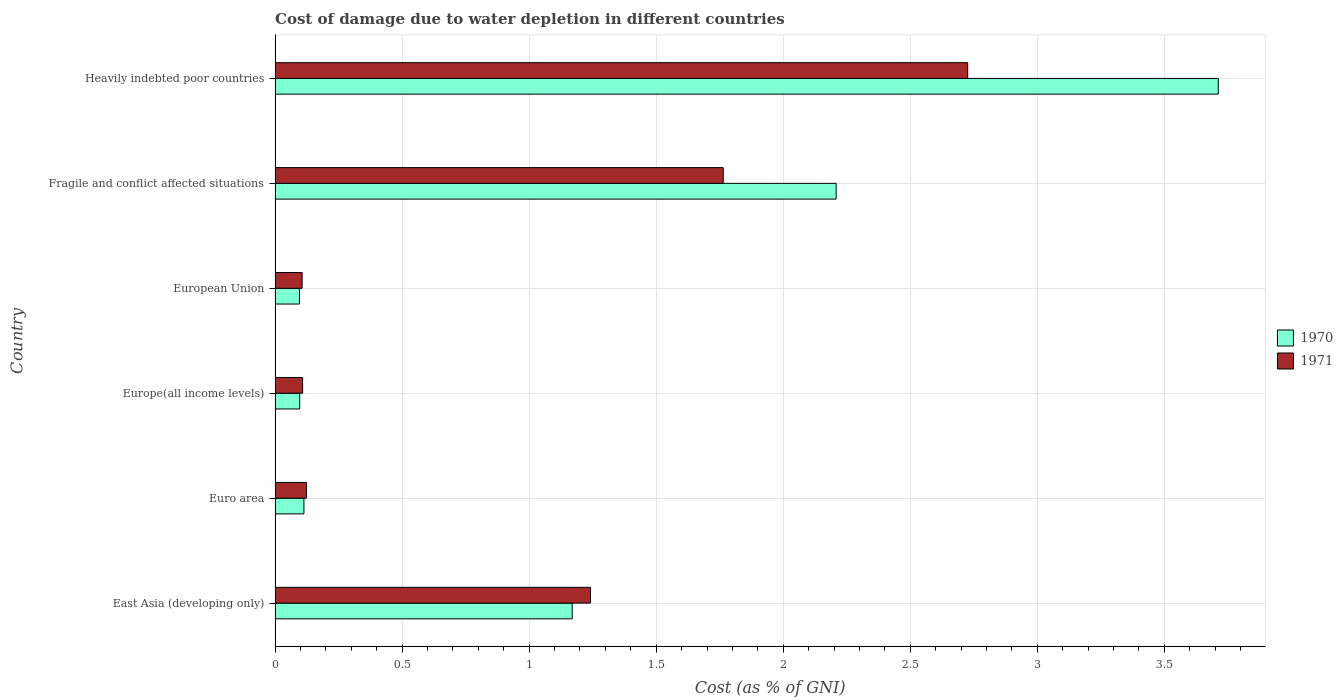How many different coloured bars are there?
Your response must be concise. 2. Are the number of bars per tick equal to the number of legend labels?
Provide a succinct answer. Yes. Are the number of bars on each tick of the Y-axis equal?
Provide a short and direct response. Yes. What is the label of the 2nd group of bars from the top?
Offer a very short reply. Fragile and conflict affected situations. What is the cost of damage caused due to water depletion in 1970 in Europe(all income levels)?
Provide a short and direct response. 0.1. Across all countries, what is the maximum cost of damage caused due to water depletion in 1971?
Give a very brief answer. 2.73. Across all countries, what is the minimum cost of damage caused due to water depletion in 1971?
Provide a short and direct response. 0.11. In which country was the cost of damage caused due to water depletion in 1971 maximum?
Your answer should be very brief. Heavily indebted poor countries. What is the total cost of damage caused due to water depletion in 1970 in the graph?
Offer a terse response. 7.4. What is the difference between the cost of damage caused due to water depletion in 1970 in European Union and that in Fragile and conflict affected situations?
Your answer should be compact. -2.11. What is the difference between the cost of damage caused due to water depletion in 1971 in European Union and the cost of damage caused due to water depletion in 1970 in Fragile and conflict affected situations?
Keep it short and to the point. -2.1. What is the average cost of damage caused due to water depletion in 1970 per country?
Your response must be concise. 1.23. What is the difference between the cost of damage caused due to water depletion in 1971 and cost of damage caused due to water depletion in 1970 in Heavily indebted poor countries?
Offer a terse response. -0.99. In how many countries, is the cost of damage caused due to water depletion in 1970 greater than 1.9 %?
Ensure brevity in your answer.  2. What is the ratio of the cost of damage caused due to water depletion in 1970 in Europe(all income levels) to that in European Union?
Your response must be concise. 1.01. Is the cost of damage caused due to water depletion in 1970 in Fragile and conflict affected situations less than that in Heavily indebted poor countries?
Offer a terse response. Yes. What is the difference between the highest and the second highest cost of damage caused due to water depletion in 1971?
Keep it short and to the point. 0.96. What is the difference between the highest and the lowest cost of damage caused due to water depletion in 1971?
Your answer should be compact. 2.62. How many bars are there?
Your response must be concise. 12. What is the difference between two consecutive major ticks on the X-axis?
Give a very brief answer. 0.5. Are the values on the major ticks of X-axis written in scientific E-notation?
Ensure brevity in your answer.  No. Does the graph contain grids?
Ensure brevity in your answer.  Yes. How are the legend labels stacked?
Offer a terse response. Vertical. What is the title of the graph?
Give a very brief answer. Cost of damage due to water depletion in different countries. Does "1963" appear as one of the legend labels in the graph?
Ensure brevity in your answer.  No. What is the label or title of the X-axis?
Offer a terse response. Cost (as % of GNI). What is the label or title of the Y-axis?
Provide a short and direct response. Country. What is the Cost (as % of GNI) in 1970 in East Asia (developing only)?
Give a very brief answer. 1.17. What is the Cost (as % of GNI) in 1971 in East Asia (developing only)?
Offer a terse response. 1.24. What is the Cost (as % of GNI) of 1970 in Euro area?
Your answer should be very brief. 0.11. What is the Cost (as % of GNI) of 1971 in Euro area?
Offer a terse response. 0.12. What is the Cost (as % of GNI) in 1970 in Europe(all income levels)?
Make the answer very short. 0.1. What is the Cost (as % of GNI) of 1971 in Europe(all income levels)?
Your answer should be very brief. 0.11. What is the Cost (as % of GNI) in 1970 in European Union?
Give a very brief answer. 0.1. What is the Cost (as % of GNI) in 1971 in European Union?
Make the answer very short. 0.11. What is the Cost (as % of GNI) in 1970 in Fragile and conflict affected situations?
Offer a very short reply. 2.21. What is the Cost (as % of GNI) in 1971 in Fragile and conflict affected situations?
Provide a succinct answer. 1.76. What is the Cost (as % of GNI) of 1970 in Heavily indebted poor countries?
Provide a short and direct response. 3.71. What is the Cost (as % of GNI) of 1971 in Heavily indebted poor countries?
Provide a succinct answer. 2.73. Across all countries, what is the maximum Cost (as % of GNI) of 1970?
Ensure brevity in your answer.  3.71. Across all countries, what is the maximum Cost (as % of GNI) of 1971?
Your answer should be very brief. 2.73. Across all countries, what is the minimum Cost (as % of GNI) of 1970?
Ensure brevity in your answer.  0.1. Across all countries, what is the minimum Cost (as % of GNI) of 1971?
Your answer should be compact. 0.11. What is the total Cost (as % of GNI) of 1970 in the graph?
Your response must be concise. 7.4. What is the total Cost (as % of GNI) of 1971 in the graph?
Ensure brevity in your answer.  6.07. What is the difference between the Cost (as % of GNI) in 1970 in East Asia (developing only) and that in Euro area?
Your answer should be compact. 1.06. What is the difference between the Cost (as % of GNI) of 1971 in East Asia (developing only) and that in Euro area?
Make the answer very short. 1.12. What is the difference between the Cost (as % of GNI) of 1970 in East Asia (developing only) and that in Europe(all income levels)?
Offer a terse response. 1.07. What is the difference between the Cost (as % of GNI) of 1971 in East Asia (developing only) and that in Europe(all income levels)?
Make the answer very short. 1.13. What is the difference between the Cost (as % of GNI) of 1970 in East Asia (developing only) and that in European Union?
Offer a very short reply. 1.07. What is the difference between the Cost (as % of GNI) of 1971 in East Asia (developing only) and that in European Union?
Your answer should be very brief. 1.13. What is the difference between the Cost (as % of GNI) of 1970 in East Asia (developing only) and that in Fragile and conflict affected situations?
Offer a very short reply. -1.04. What is the difference between the Cost (as % of GNI) in 1971 in East Asia (developing only) and that in Fragile and conflict affected situations?
Give a very brief answer. -0.52. What is the difference between the Cost (as % of GNI) in 1970 in East Asia (developing only) and that in Heavily indebted poor countries?
Offer a terse response. -2.54. What is the difference between the Cost (as % of GNI) of 1971 in East Asia (developing only) and that in Heavily indebted poor countries?
Provide a short and direct response. -1.48. What is the difference between the Cost (as % of GNI) in 1970 in Euro area and that in Europe(all income levels)?
Provide a succinct answer. 0.02. What is the difference between the Cost (as % of GNI) of 1971 in Euro area and that in Europe(all income levels)?
Ensure brevity in your answer.  0.02. What is the difference between the Cost (as % of GNI) in 1970 in Euro area and that in European Union?
Provide a short and direct response. 0.02. What is the difference between the Cost (as % of GNI) of 1971 in Euro area and that in European Union?
Give a very brief answer. 0.02. What is the difference between the Cost (as % of GNI) in 1970 in Euro area and that in Fragile and conflict affected situations?
Your answer should be very brief. -2.09. What is the difference between the Cost (as % of GNI) of 1971 in Euro area and that in Fragile and conflict affected situations?
Your answer should be very brief. -1.64. What is the difference between the Cost (as % of GNI) of 1970 in Euro area and that in Heavily indebted poor countries?
Offer a very short reply. -3.6. What is the difference between the Cost (as % of GNI) in 1971 in Euro area and that in Heavily indebted poor countries?
Keep it short and to the point. -2.6. What is the difference between the Cost (as % of GNI) in 1970 in Europe(all income levels) and that in European Union?
Offer a terse response. 0. What is the difference between the Cost (as % of GNI) in 1971 in Europe(all income levels) and that in European Union?
Your response must be concise. 0. What is the difference between the Cost (as % of GNI) in 1970 in Europe(all income levels) and that in Fragile and conflict affected situations?
Offer a terse response. -2.11. What is the difference between the Cost (as % of GNI) of 1971 in Europe(all income levels) and that in Fragile and conflict affected situations?
Your answer should be compact. -1.66. What is the difference between the Cost (as % of GNI) of 1970 in Europe(all income levels) and that in Heavily indebted poor countries?
Ensure brevity in your answer.  -3.62. What is the difference between the Cost (as % of GNI) in 1971 in Europe(all income levels) and that in Heavily indebted poor countries?
Offer a terse response. -2.62. What is the difference between the Cost (as % of GNI) in 1970 in European Union and that in Fragile and conflict affected situations?
Your response must be concise. -2.11. What is the difference between the Cost (as % of GNI) of 1971 in European Union and that in Fragile and conflict affected situations?
Keep it short and to the point. -1.66. What is the difference between the Cost (as % of GNI) in 1970 in European Union and that in Heavily indebted poor countries?
Your answer should be very brief. -3.62. What is the difference between the Cost (as % of GNI) in 1971 in European Union and that in Heavily indebted poor countries?
Your answer should be very brief. -2.62. What is the difference between the Cost (as % of GNI) in 1970 in Fragile and conflict affected situations and that in Heavily indebted poor countries?
Your answer should be very brief. -1.5. What is the difference between the Cost (as % of GNI) of 1971 in Fragile and conflict affected situations and that in Heavily indebted poor countries?
Ensure brevity in your answer.  -0.96. What is the difference between the Cost (as % of GNI) of 1970 in East Asia (developing only) and the Cost (as % of GNI) of 1971 in Euro area?
Your response must be concise. 1.05. What is the difference between the Cost (as % of GNI) of 1970 in East Asia (developing only) and the Cost (as % of GNI) of 1971 in Europe(all income levels)?
Offer a very short reply. 1.06. What is the difference between the Cost (as % of GNI) of 1970 in East Asia (developing only) and the Cost (as % of GNI) of 1971 in European Union?
Make the answer very short. 1.06. What is the difference between the Cost (as % of GNI) of 1970 in East Asia (developing only) and the Cost (as % of GNI) of 1971 in Fragile and conflict affected situations?
Your response must be concise. -0.59. What is the difference between the Cost (as % of GNI) in 1970 in East Asia (developing only) and the Cost (as % of GNI) in 1971 in Heavily indebted poor countries?
Your answer should be very brief. -1.56. What is the difference between the Cost (as % of GNI) in 1970 in Euro area and the Cost (as % of GNI) in 1971 in Europe(all income levels)?
Offer a very short reply. 0.01. What is the difference between the Cost (as % of GNI) of 1970 in Euro area and the Cost (as % of GNI) of 1971 in European Union?
Make the answer very short. 0.01. What is the difference between the Cost (as % of GNI) in 1970 in Euro area and the Cost (as % of GNI) in 1971 in Fragile and conflict affected situations?
Give a very brief answer. -1.65. What is the difference between the Cost (as % of GNI) in 1970 in Euro area and the Cost (as % of GNI) in 1971 in Heavily indebted poor countries?
Your response must be concise. -2.61. What is the difference between the Cost (as % of GNI) in 1970 in Europe(all income levels) and the Cost (as % of GNI) in 1971 in European Union?
Keep it short and to the point. -0.01. What is the difference between the Cost (as % of GNI) in 1970 in Europe(all income levels) and the Cost (as % of GNI) in 1971 in Fragile and conflict affected situations?
Ensure brevity in your answer.  -1.67. What is the difference between the Cost (as % of GNI) in 1970 in Europe(all income levels) and the Cost (as % of GNI) in 1971 in Heavily indebted poor countries?
Keep it short and to the point. -2.63. What is the difference between the Cost (as % of GNI) of 1970 in European Union and the Cost (as % of GNI) of 1971 in Fragile and conflict affected situations?
Offer a terse response. -1.67. What is the difference between the Cost (as % of GNI) in 1970 in European Union and the Cost (as % of GNI) in 1971 in Heavily indebted poor countries?
Offer a terse response. -2.63. What is the difference between the Cost (as % of GNI) of 1970 in Fragile and conflict affected situations and the Cost (as % of GNI) of 1971 in Heavily indebted poor countries?
Make the answer very short. -0.52. What is the average Cost (as % of GNI) of 1970 per country?
Provide a succinct answer. 1.23. What is the average Cost (as % of GNI) of 1971 per country?
Offer a terse response. 1.01. What is the difference between the Cost (as % of GNI) in 1970 and Cost (as % of GNI) in 1971 in East Asia (developing only)?
Your answer should be very brief. -0.07. What is the difference between the Cost (as % of GNI) of 1970 and Cost (as % of GNI) of 1971 in Euro area?
Keep it short and to the point. -0.01. What is the difference between the Cost (as % of GNI) in 1970 and Cost (as % of GNI) in 1971 in Europe(all income levels)?
Offer a terse response. -0.01. What is the difference between the Cost (as % of GNI) in 1970 and Cost (as % of GNI) in 1971 in European Union?
Your response must be concise. -0.01. What is the difference between the Cost (as % of GNI) of 1970 and Cost (as % of GNI) of 1971 in Fragile and conflict affected situations?
Keep it short and to the point. 0.44. What is the difference between the Cost (as % of GNI) of 1970 and Cost (as % of GNI) of 1971 in Heavily indebted poor countries?
Give a very brief answer. 0.99. What is the ratio of the Cost (as % of GNI) of 1970 in East Asia (developing only) to that in Euro area?
Offer a very short reply. 10.3. What is the ratio of the Cost (as % of GNI) in 1971 in East Asia (developing only) to that in Euro area?
Your answer should be compact. 10.06. What is the ratio of the Cost (as % of GNI) in 1970 in East Asia (developing only) to that in Europe(all income levels)?
Provide a short and direct response. 12.06. What is the ratio of the Cost (as % of GNI) in 1971 in East Asia (developing only) to that in Europe(all income levels)?
Keep it short and to the point. 11.46. What is the ratio of the Cost (as % of GNI) of 1970 in East Asia (developing only) to that in European Union?
Your answer should be compact. 12.18. What is the ratio of the Cost (as % of GNI) of 1971 in East Asia (developing only) to that in European Union?
Make the answer very short. 11.67. What is the ratio of the Cost (as % of GNI) of 1970 in East Asia (developing only) to that in Fragile and conflict affected situations?
Provide a short and direct response. 0.53. What is the ratio of the Cost (as % of GNI) of 1971 in East Asia (developing only) to that in Fragile and conflict affected situations?
Keep it short and to the point. 0.7. What is the ratio of the Cost (as % of GNI) in 1970 in East Asia (developing only) to that in Heavily indebted poor countries?
Your answer should be compact. 0.32. What is the ratio of the Cost (as % of GNI) in 1971 in East Asia (developing only) to that in Heavily indebted poor countries?
Give a very brief answer. 0.46. What is the ratio of the Cost (as % of GNI) in 1970 in Euro area to that in Europe(all income levels)?
Your answer should be compact. 1.17. What is the ratio of the Cost (as % of GNI) in 1971 in Euro area to that in Europe(all income levels)?
Make the answer very short. 1.14. What is the ratio of the Cost (as % of GNI) of 1970 in Euro area to that in European Union?
Ensure brevity in your answer.  1.18. What is the ratio of the Cost (as % of GNI) in 1971 in Euro area to that in European Union?
Give a very brief answer. 1.16. What is the ratio of the Cost (as % of GNI) in 1970 in Euro area to that in Fragile and conflict affected situations?
Your answer should be compact. 0.05. What is the ratio of the Cost (as % of GNI) of 1971 in Euro area to that in Fragile and conflict affected situations?
Offer a very short reply. 0.07. What is the ratio of the Cost (as % of GNI) in 1970 in Euro area to that in Heavily indebted poor countries?
Provide a succinct answer. 0.03. What is the ratio of the Cost (as % of GNI) of 1971 in Euro area to that in Heavily indebted poor countries?
Your answer should be compact. 0.05. What is the ratio of the Cost (as % of GNI) in 1970 in Europe(all income levels) to that in European Union?
Ensure brevity in your answer.  1.01. What is the ratio of the Cost (as % of GNI) in 1971 in Europe(all income levels) to that in European Union?
Ensure brevity in your answer.  1.02. What is the ratio of the Cost (as % of GNI) in 1970 in Europe(all income levels) to that in Fragile and conflict affected situations?
Ensure brevity in your answer.  0.04. What is the ratio of the Cost (as % of GNI) of 1971 in Europe(all income levels) to that in Fragile and conflict affected situations?
Your answer should be compact. 0.06. What is the ratio of the Cost (as % of GNI) of 1970 in Europe(all income levels) to that in Heavily indebted poor countries?
Make the answer very short. 0.03. What is the ratio of the Cost (as % of GNI) in 1971 in Europe(all income levels) to that in Heavily indebted poor countries?
Offer a terse response. 0.04. What is the ratio of the Cost (as % of GNI) of 1970 in European Union to that in Fragile and conflict affected situations?
Give a very brief answer. 0.04. What is the ratio of the Cost (as % of GNI) of 1971 in European Union to that in Fragile and conflict affected situations?
Offer a very short reply. 0.06. What is the ratio of the Cost (as % of GNI) in 1970 in European Union to that in Heavily indebted poor countries?
Ensure brevity in your answer.  0.03. What is the ratio of the Cost (as % of GNI) in 1971 in European Union to that in Heavily indebted poor countries?
Your answer should be compact. 0.04. What is the ratio of the Cost (as % of GNI) in 1970 in Fragile and conflict affected situations to that in Heavily indebted poor countries?
Offer a very short reply. 0.59. What is the ratio of the Cost (as % of GNI) in 1971 in Fragile and conflict affected situations to that in Heavily indebted poor countries?
Your response must be concise. 0.65. What is the difference between the highest and the second highest Cost (as % of GNI) in 1970?
Ensure brevity in your answer.  1.5. What is the difference between the highest and the second highest Cost (as % of GNI) of 1971?
Give a very brief answer. 0.96. What is the difference between the highest and the lowest Cost (as % of GNI) of 1970?
Your answer should be compact. 3.62. What is the difference between the highest and the lowest Cost (as % of GNI) in 1971?
Offer a very short reply. 2.62. 